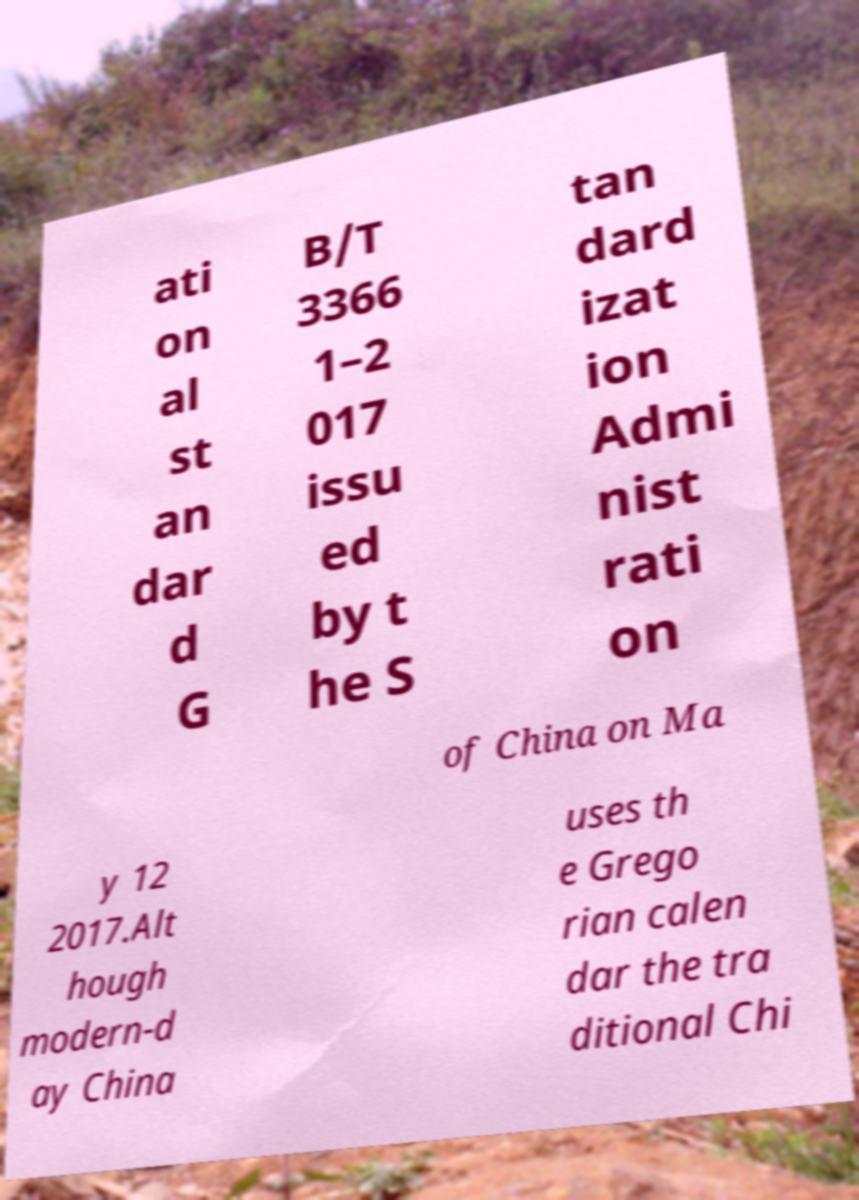For documentation purposes, I need the text within this image transcribed. Could you provide that? ati on al st an dar d G B/T 3366 1–2 017 issu ed by t he S tan dard izat ion Admi nist rati on of China on Ma y 12 2017.Alt hough modern-d ay China uses th e Grego rian calen dar the tra ditional Chi 